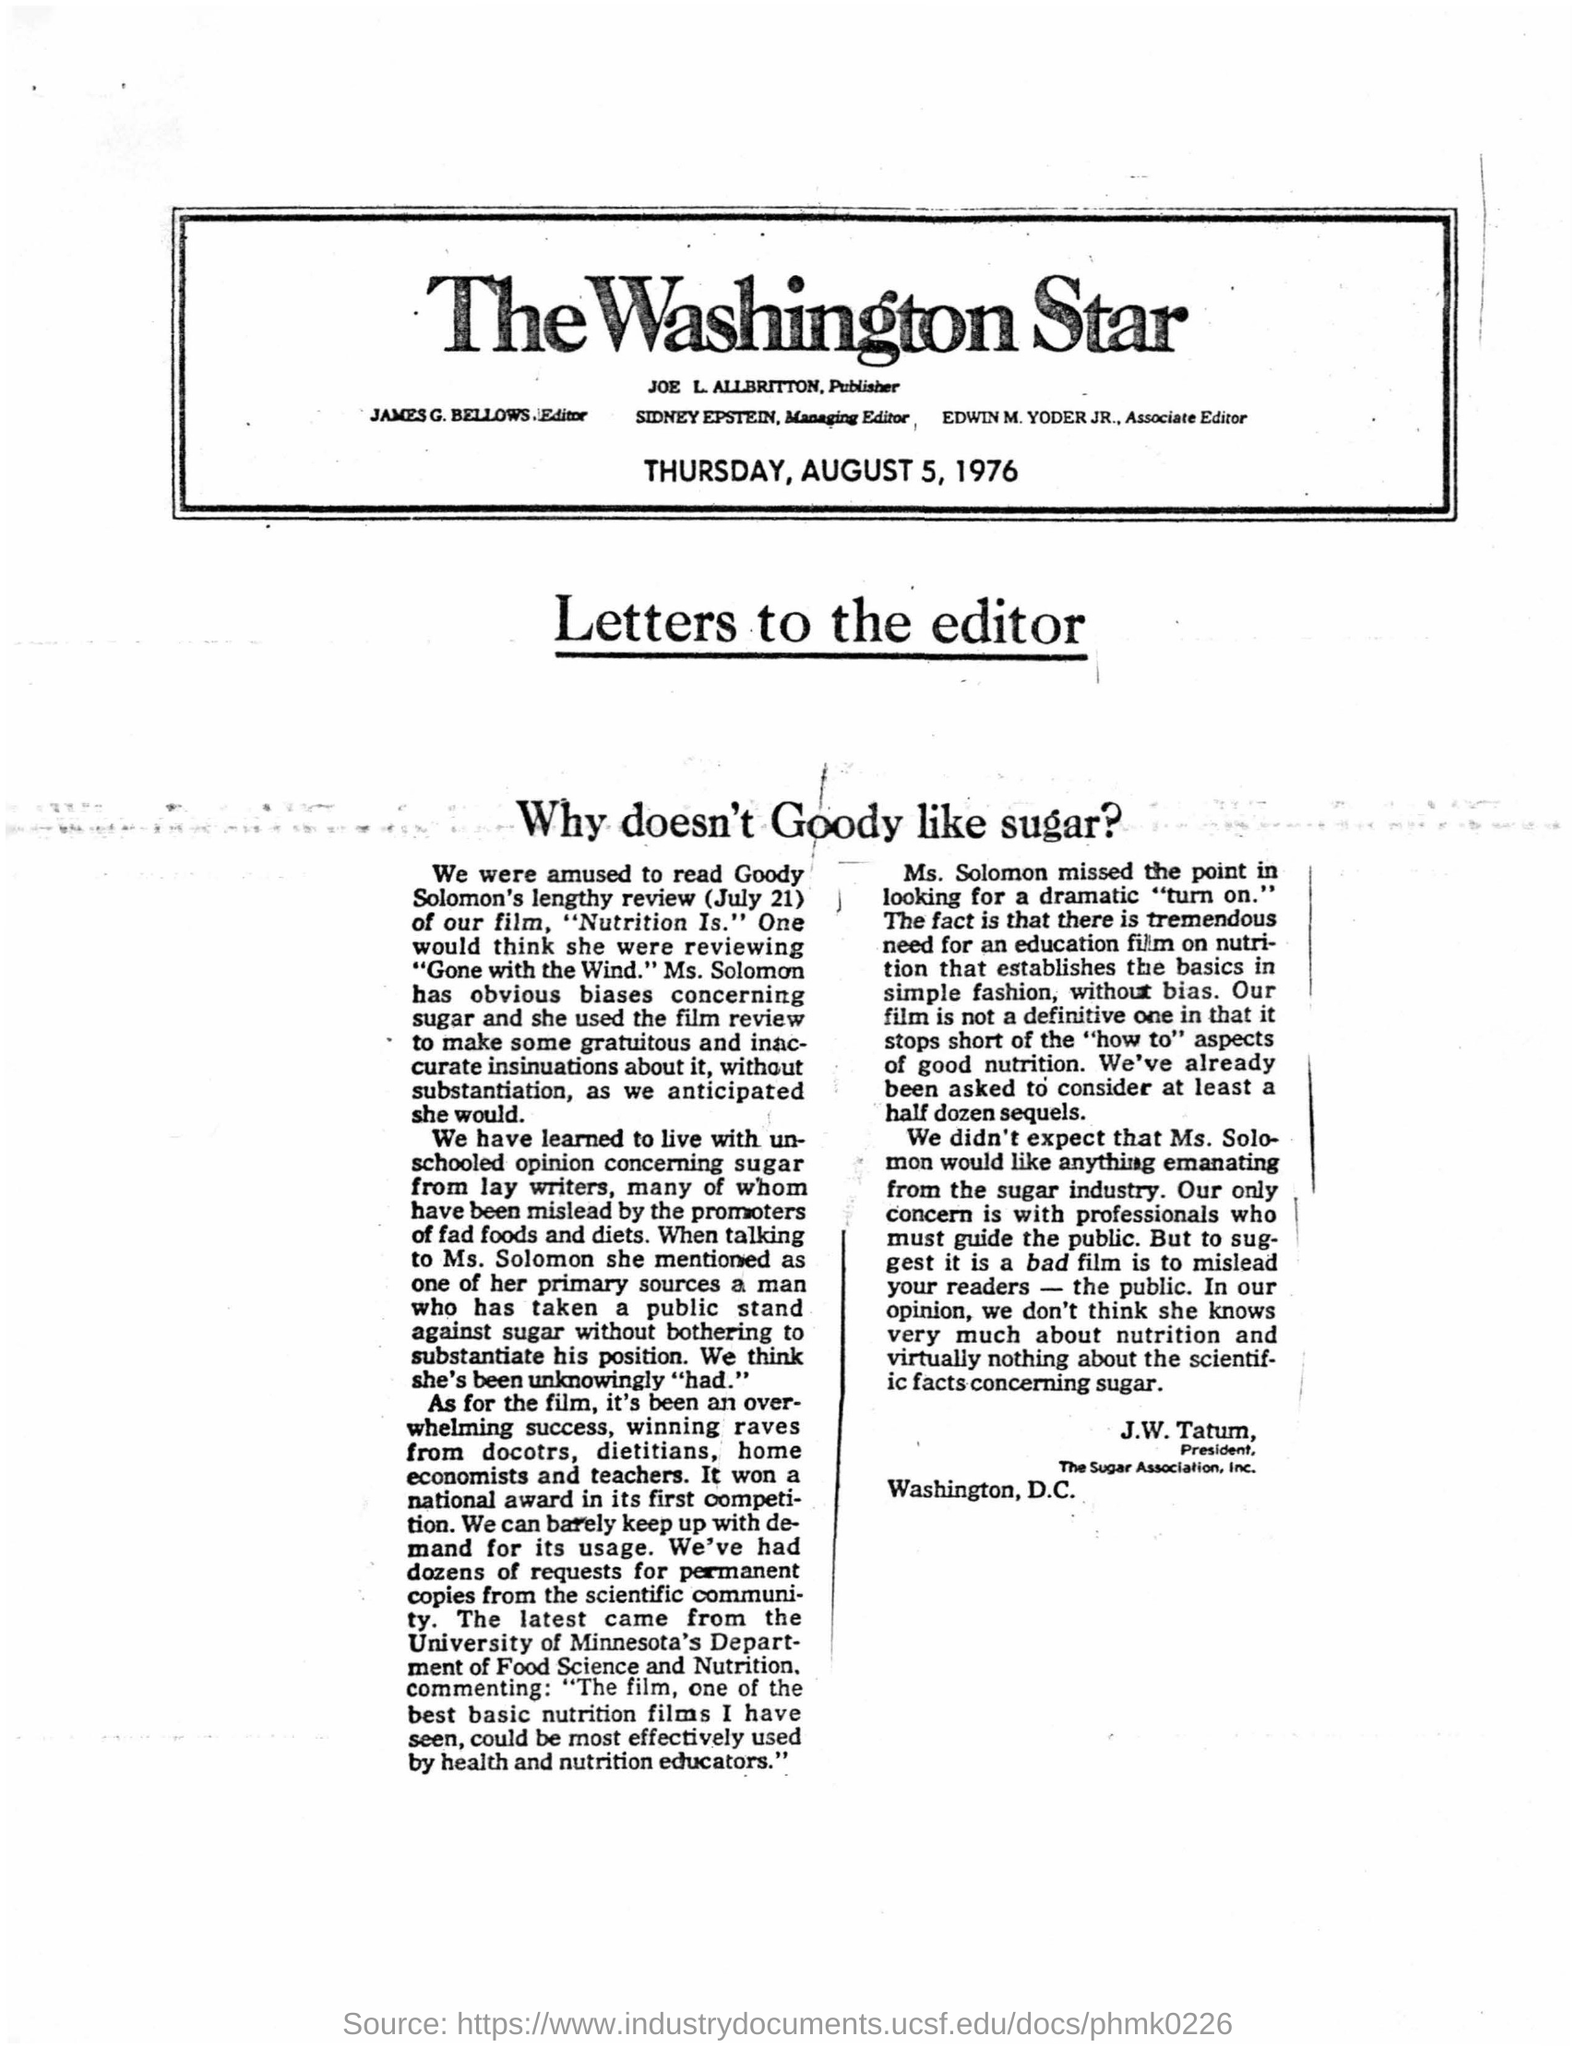When is the article printed on?
Provide a succinct answer. Thursday, august 5, 1976. Who is the editor?
Your answer should be very brief. James G. Bellows. Who is the managing editor?
Make the answer very short. Sidney Epstein. Who is the President of the Sugar Association, Inc.?
Your answer should be compact. J.W. Tatum. 